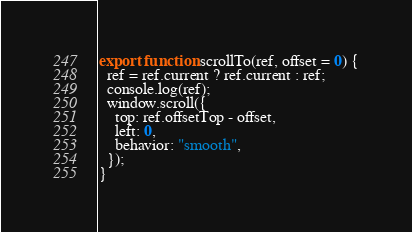<code> <loc_0><loc_0><loc_500><loc_500><_JavaScript_>export function scrollTo(ref, offset = 0) {
  ref = ref.current ? ref.current : ref;
  console.log(ref);
  window.scroll({
    top: ref.offsetTop - offset,
    left: 0,
    behavior: "smooth",
  });
}
</code> 